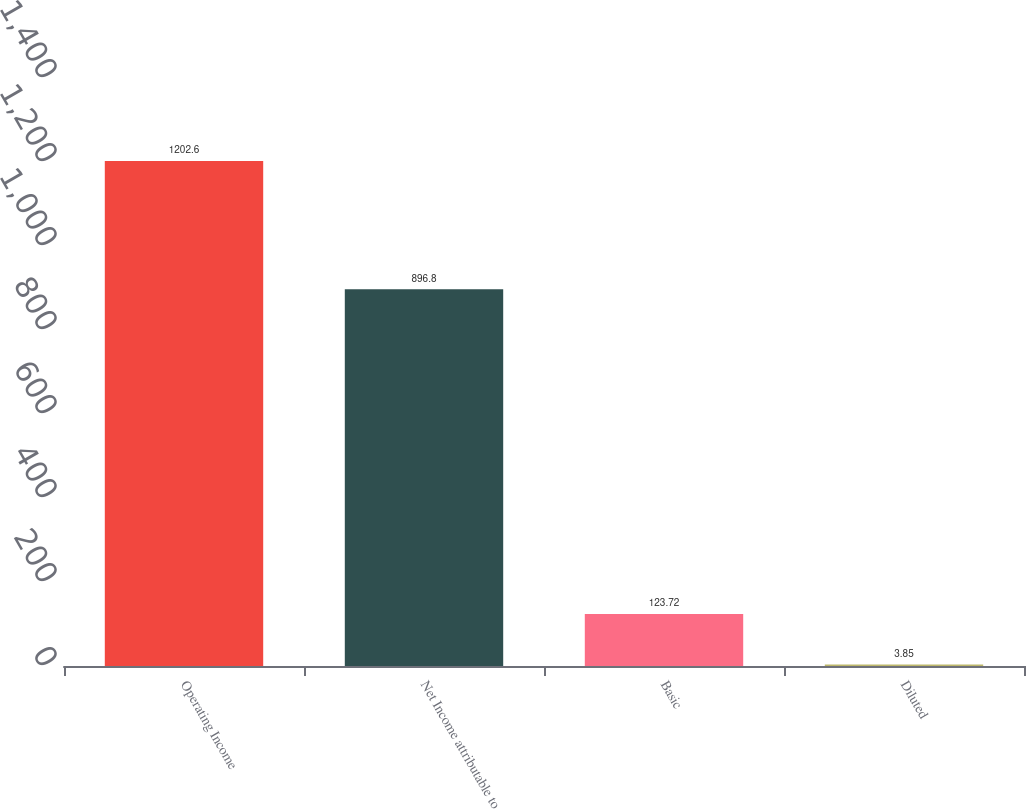Convert chart. <chart><loc_0><loc_0><loc_500><loc_500><bar_chart><fcel>Operating Income<fcel>Net Income attributable to<fcel>Basic<fcel>Diluted<nl><fcel>1202.6<fcel>896.8<fcel>123.72<fcel>3.85<nl></chart> 